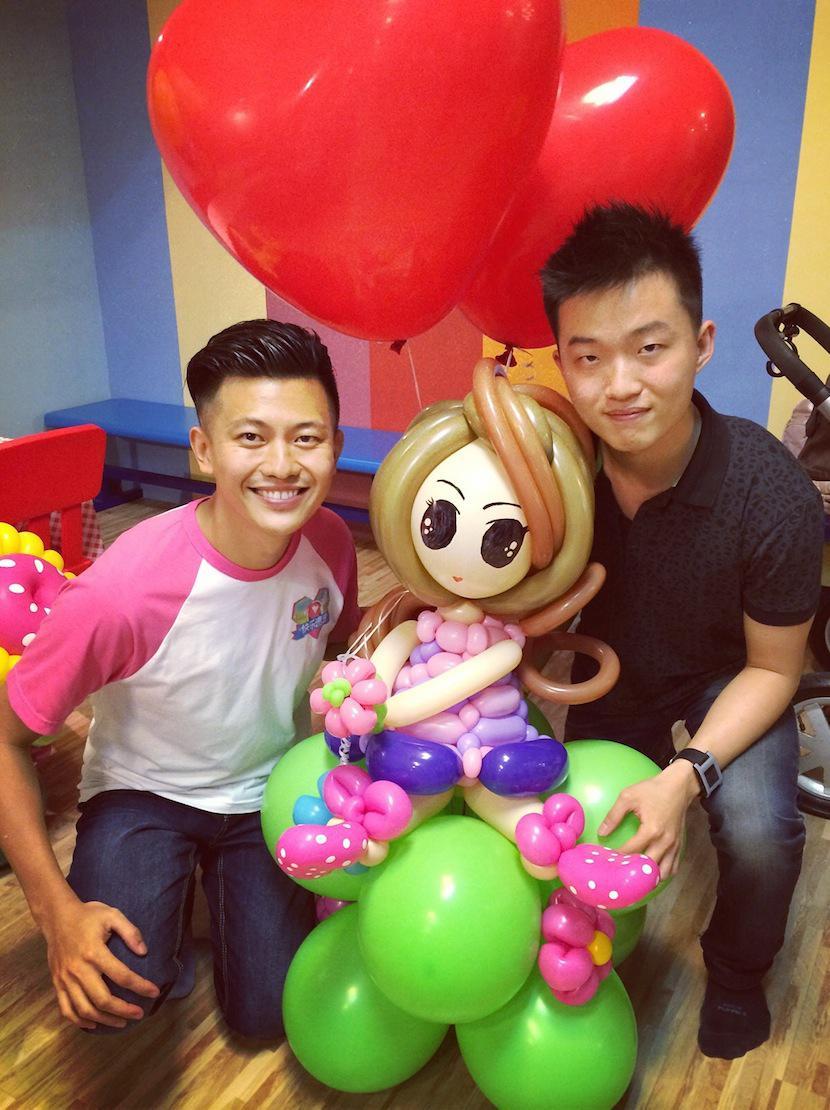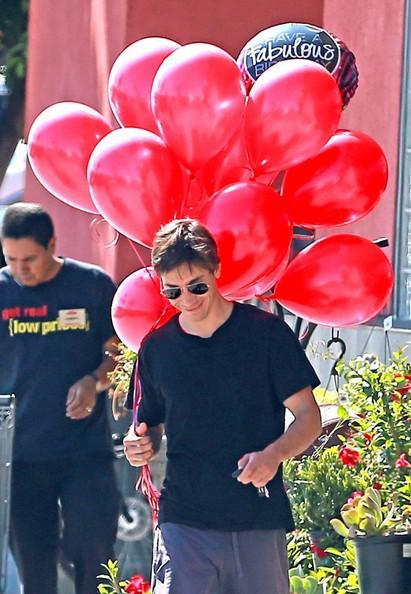The first image is the image on the left, the second image is the image on the right. Examine the images to the left and right. Is the description "There is a heart shaped balloon in both images." accurate? Answer yes or no. No. The first image is the image on the left, the second image is the image on the right. Considering the images on both sides, is "There is a man outside walking with at least ten red balloons." valid? Answer yes or no. Yes. 